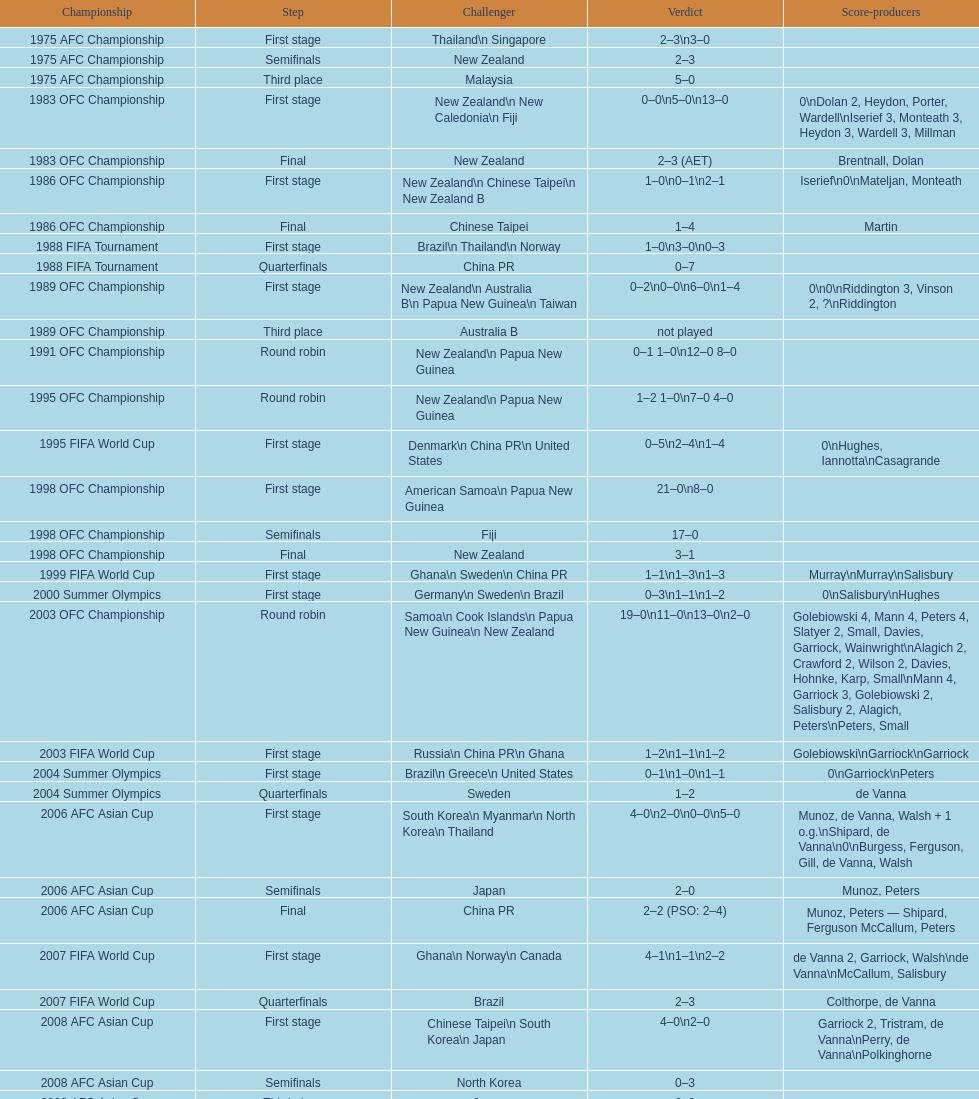How many stages were round robins? 3. 